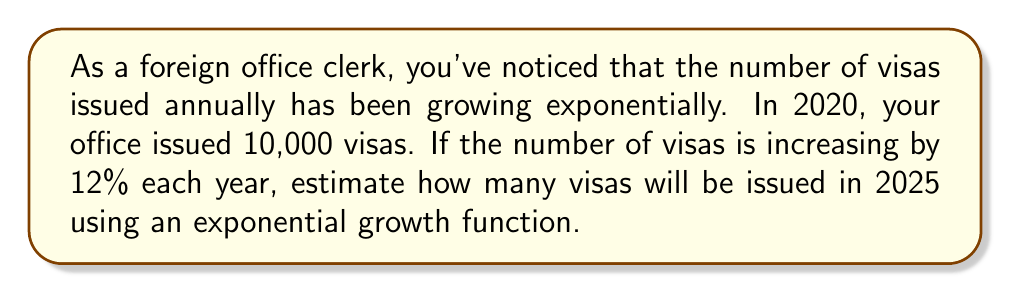Solve this math problem. Let's approach this step-by-step using an exponential growth function:

1) The general form of an exponential growth function is:
   $A(t) = A_0(1 + r)^t$
   Where:
   $A(t)$ is the amount after time $t$
   $A_0$ is the initial amount
   $r$ is the growth rate (as a decimal)
   $t$ is the time period

2) Given information:
   $A_0 = 10,000$ (initial number of visas in 2020)
   $r = 0.12$ (12% growth rate)
   $t = 5$ (number of years from 2020 to 2025)

3) Plugging these values into our function:
   $A(5) = 10,000(1 + 0.12)^5$

4) Simplify inside the parentheses:
   $A(5) = 10,000(1.12)^5$

5) Calculate the exponent:
   $(1.12)^5 \approx 1.7623$

6) Multiply:
   $A(5) = 10,000 * 1.7623 \approx 17,623$

Therefore, in 2025, approximately 17,623 visas will be issued.
Answer: 17,623 visas 